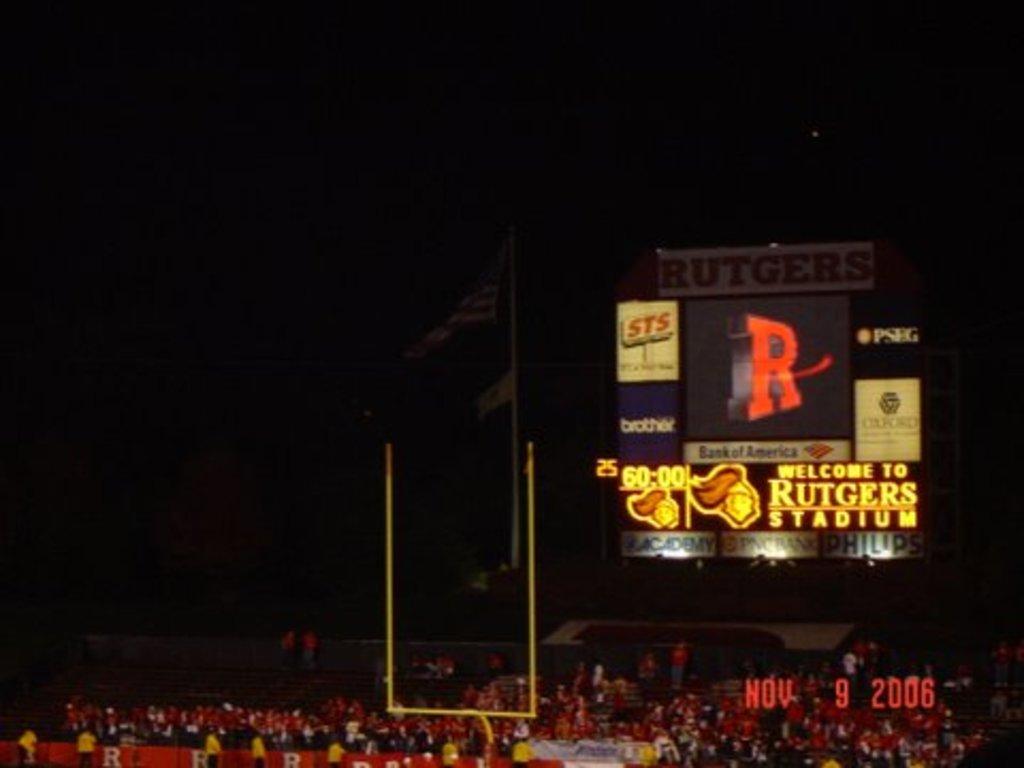When was this picture taken?
Make the answer very short. Nov 9 2006. 